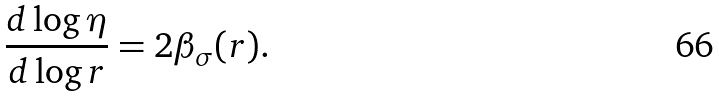Convert formula to latex. <formula><loc_0><loc_0><loc_500><loc_500>\frac { d \log \eta } { d \log r } = 2 \beta _ { \sigma } ( r ) .</formula> 